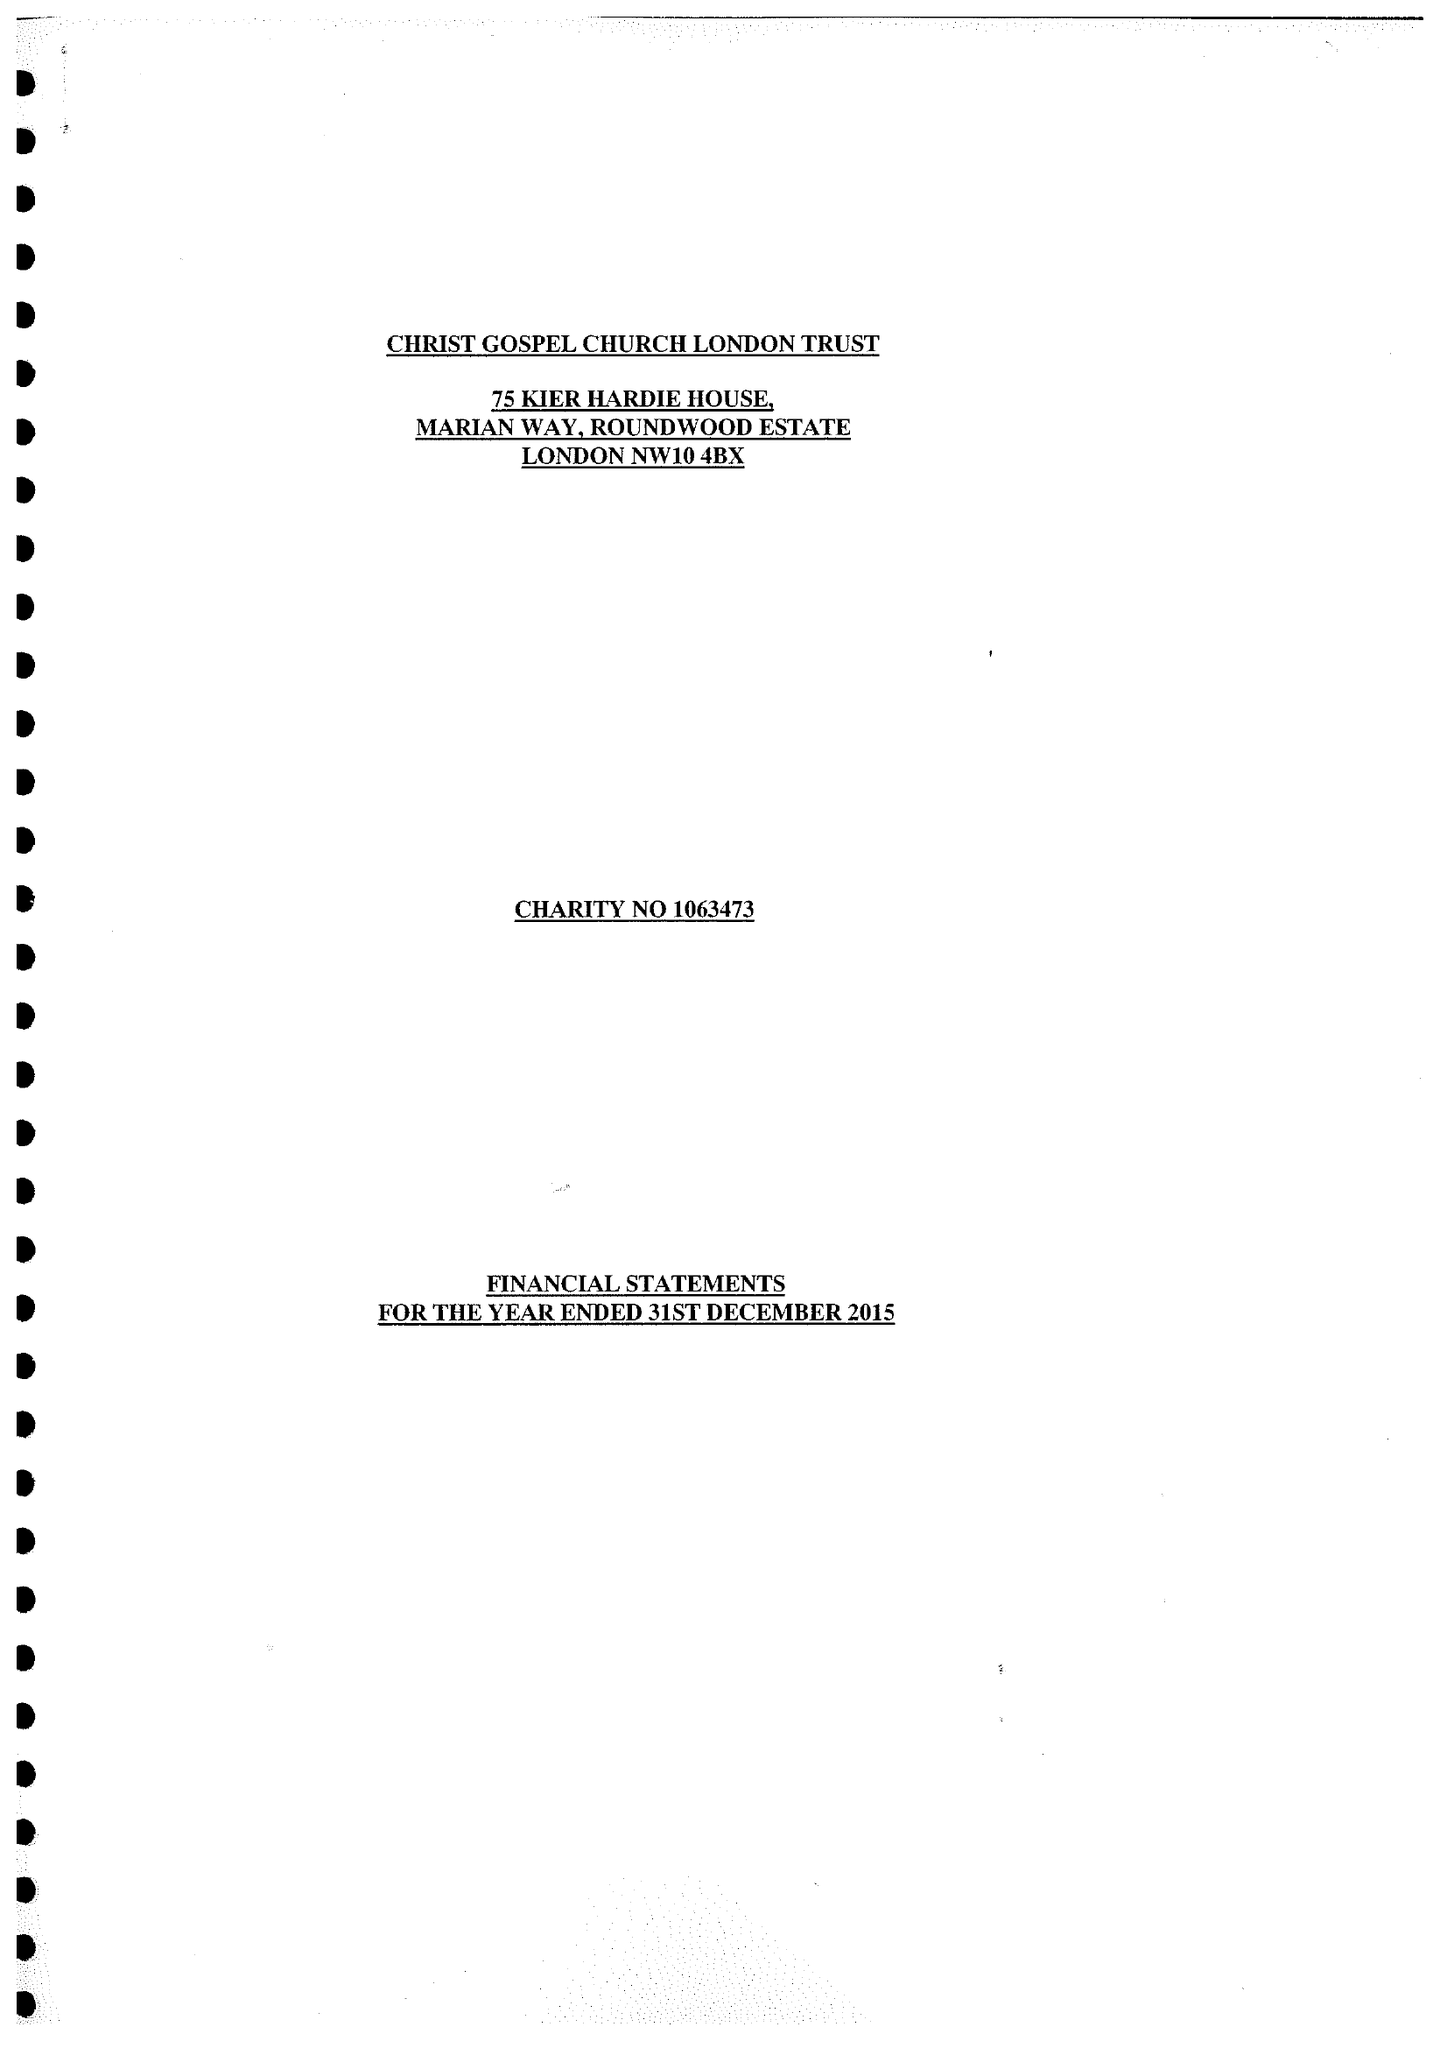What is the value for the charity_number?
Answer the question using a single word or phrase. 1063473 